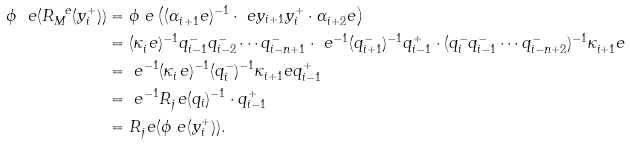<formula> <loc_0><loc_0><loc_500><loc_500>\phi _ { \ } e ( R _ { M } ^ { \ e } ( y _ { i } ^ { + } ) ) & = \phi _ { \ } e \left ( ( \alpha _ { i + 1 } ^ { \ } e ) ^ { - 1 } \cdot \ e y _ { i + 1 } y _ { i } ^ { + } \cdot \alpha _ { i + 2 } ^ { \ } e \right ) \\ & = ( \kappa _ { i } ^ { \ } e ) ^ { - 1 } q _ { i - 1 } ^ { - } q _ { i - 2 } ^ { - } \cdots q _ { i - n + 1 } ^ { - } \cdot \ e ^ { - 1 } ( q _ { i + 1 } ^ { - } ) ^ { - 1 } q _ { i - 1 } ^ { + } \cdot ( q _ { i } ^ { - } q _ { i - 1 } ^ { - } \cdots q _ { i - n + 2 } ^ { - } ) ^ { - 1 } \kappa _ { i + 1 } ^ { \ } e \\ & = \ e ^ { - 1 } ( \kappa _ { i } ^ { \ } e ) ^ { - 1 } ( q _ { i } ^ { - } ) ^ { - 1 } \kappa _ { i + 1 } ^ { \ } e q _ { i - 1 } ^ { + } \\ & = \ e ^ { - 1 } R _ { j } ^ { \ } e ( q _ { i } ) ^ { - 1 } \cdot q _ { i - 1 } ^ { + } \\ & = R _ { j } ^ { \ } e ( \phi _ { \ } e ( y _ { i } ^ { + } ) ) .</formula> 